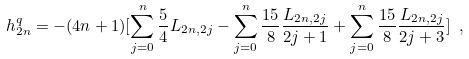Convert formula to latex. <formula><loc_0><loc_0><loc_500><loc_500>h _ { 2 n } ^ { q } = - ( 4 n + 1 ) [ \sum _ { j = 0 } ^ { n } \frac { 5 } { 4 } L _ { 2 n , 2 j } - \sum _ { j = 0 } ^ { n } \frac { 1 5 } { 8 } \frac { L _ { 2 n , 2 j } } { 2 j + 1 } + \sum _ { j = 0 } ^ { n } \frac { 1 5 } { 8 } \frac { L _ { 2 n , 2 j } } { 2 j + 3 } ] \ ,</formula> 